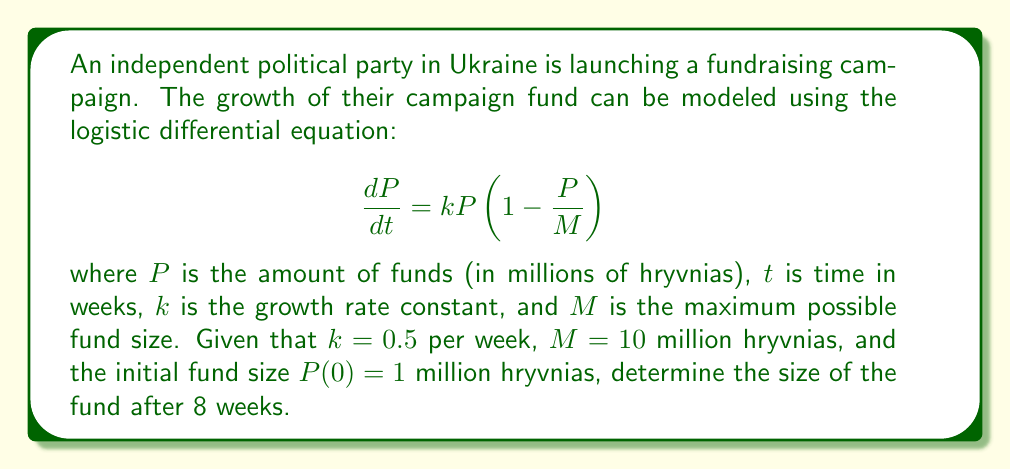Teach me how to tackle this problem. To solve this problem, we need to use the solution to the logistic differential equation:

$$P(t) = \frac{M}{1 + (\frac{M}{P_0} - 1)e^{-kt}}$$

Where:
- $M = 10$ million hryvnias (maximum fund size)
- $k = 0.5$ per week (growth rate constant)
- $P_0 = P(0) = 1$ million hryvnias (initial fund size)
- $t = 8$ weeks

Let's substitute these values into the equation:

$$P(8) = \frac{10}{1 + (\frac{10}{1} - 1)e^{-0.5(8)}}$$

Simplifying:

$$P(8) = \frac{10}{1 + 9e^{-4}}$$

Now, let's calculate $e^{-4}$:
$e^{-4} \approx 0.0183$

Substituting this value:

$$P(8) = \frac{10}{1 + 9(0.0183)} = \frac{10}{1 + 0.1647} = \frac{10}{1.1647}$$

Finally, calculating the result:

$$P(8) \approx 8.5859$$ million hryvnias
Answer: After 8 weeks, the campaign fund will grow to approximately 8.59 million hryvnias. 